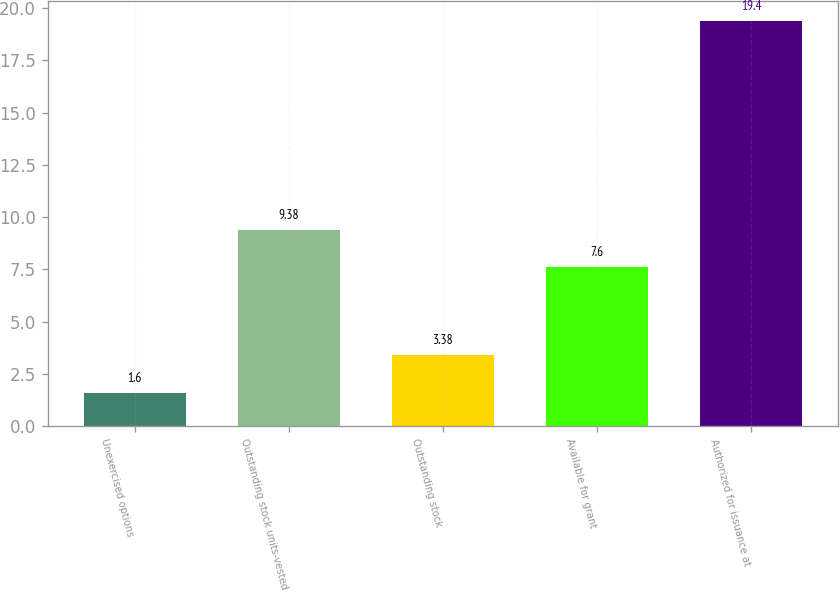Convert chart to OTSL. <chart><loc_0><loc_0><loc_500><loc_500><bar_chart><fcel>Unexercised options<fcel>Outstanding stock units-vested<fcel>Outstanding stock<fcel>Available for grant<fcel>Authorized for issuance at<nl><fcel>1.6<fcel>9.38<fcel>3.38<fcel>7.6<fcel>19.4<nl></chart> 